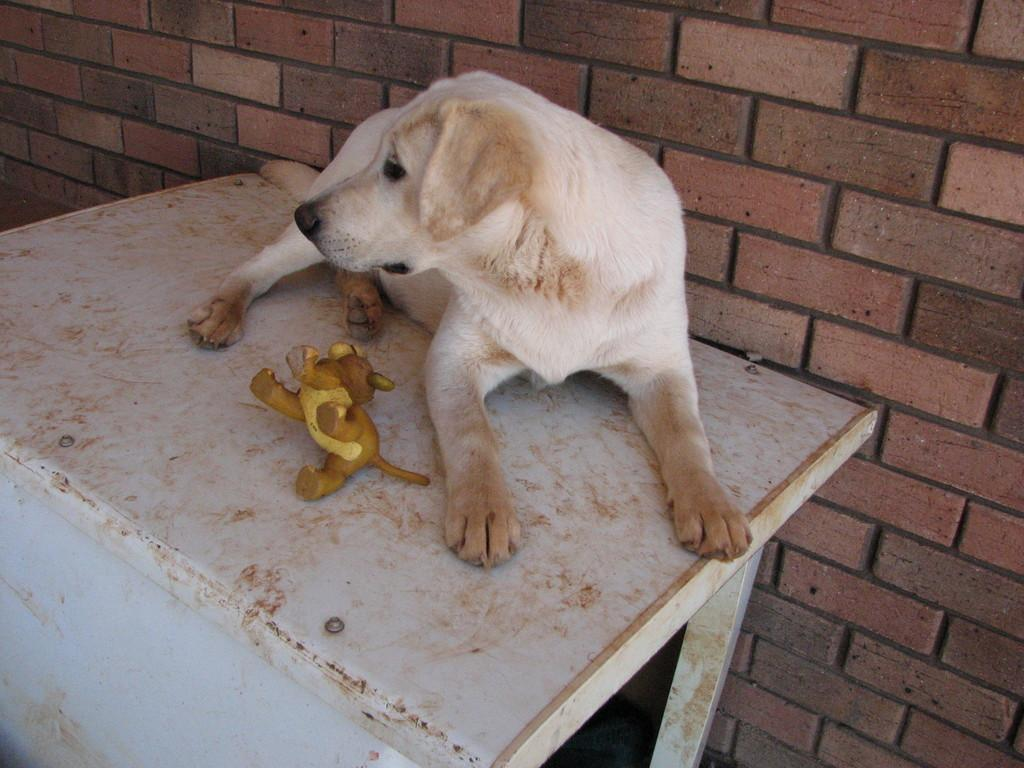What animal is on the table in the image? There is a dog on the table in the image. What can be seen in the background of the image? There is a wall in the background of the image. What type of wax is being used to create the dog's fur in the image? There is no wax present in the image; it is a photograph or illustration of a real dog. What musical instrument is being played by the dog in the image? There is no musical instrument present in the image; the dog is simply sitting on the table. 